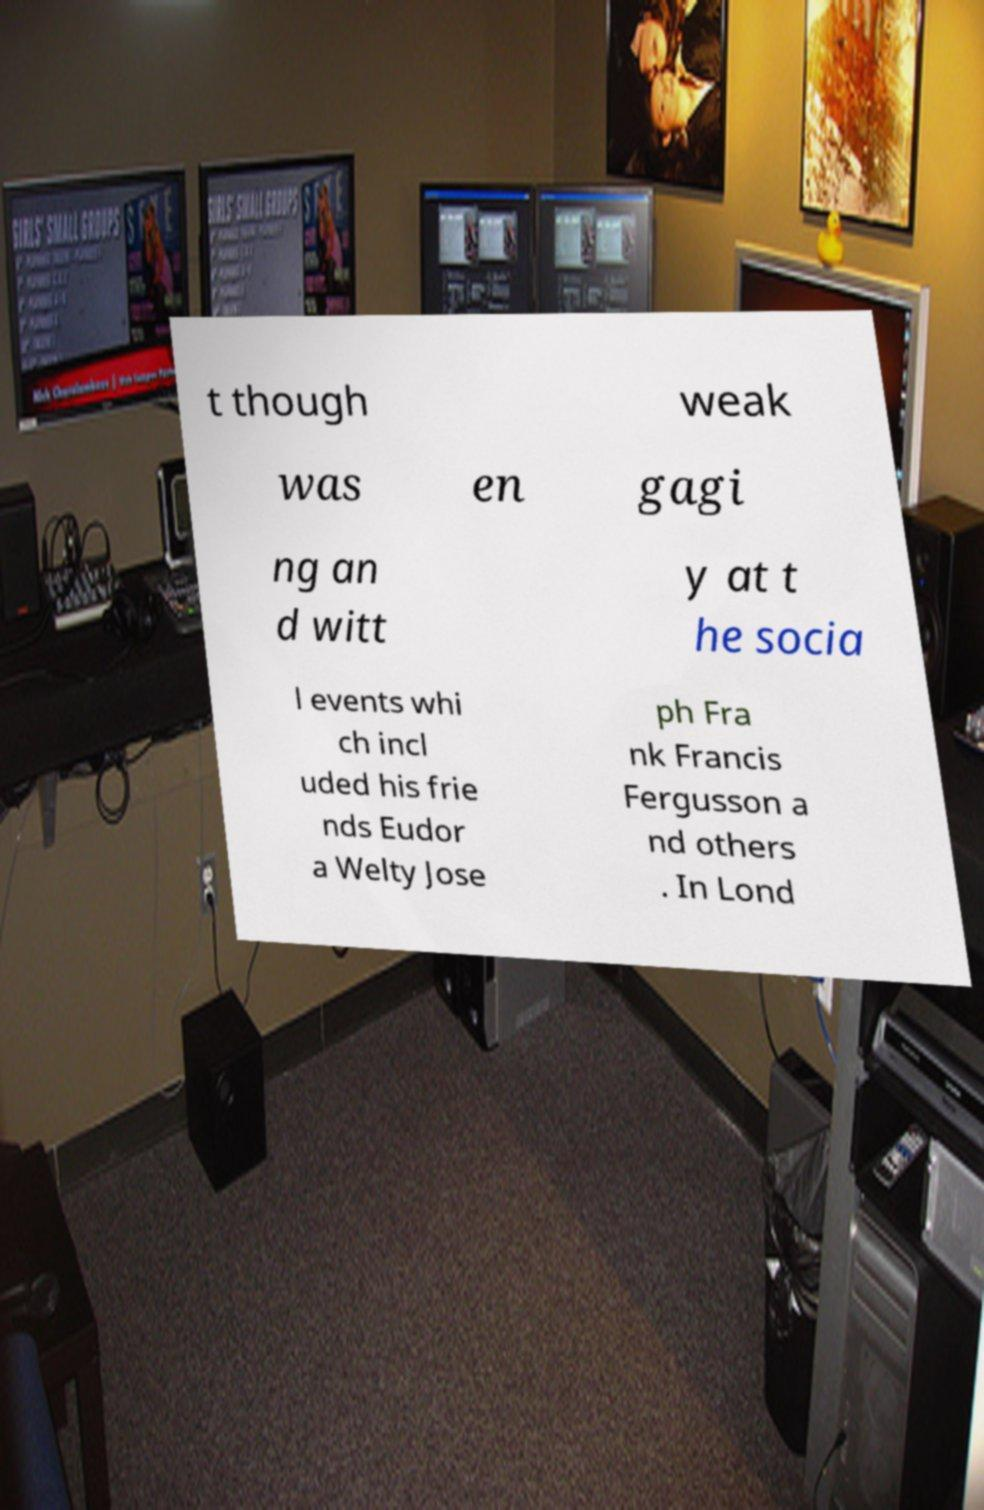Please read and relay the text visible in this image. What does it say? t though weak was en gagi ng an d witt y at t he socia l events whi ch incl uded his frie nds Eudor a Welty Jose ph Fra nk Francis Fergusson a nd others . In Lond 